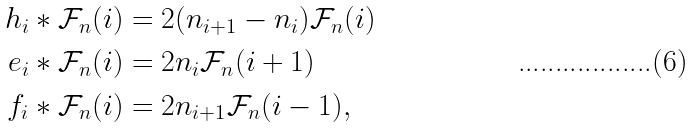Convert formula to latex. <formula><loc_0><loc_0><loc_500><loc_500>h _ { i } \ast \mathcal { F } _ { n } ( i ) & = 2 ( n _ { i + 1 } - n _ { i } ) \mathcal { F } _ { n } ( i ) \\ e _ { i } \ast \mathcal { F } _ { n } ( i ) & = 2 n _ { i } \mathcal { F } _ { n } ( i + 1 ) \\ \text { } f _ { i } \ast \mathcal { F } _ { n } ( i ) & = 2 n _ { i + 1 } \mathcal { F } _ { n } ( i - 1 ) ,</formula> 